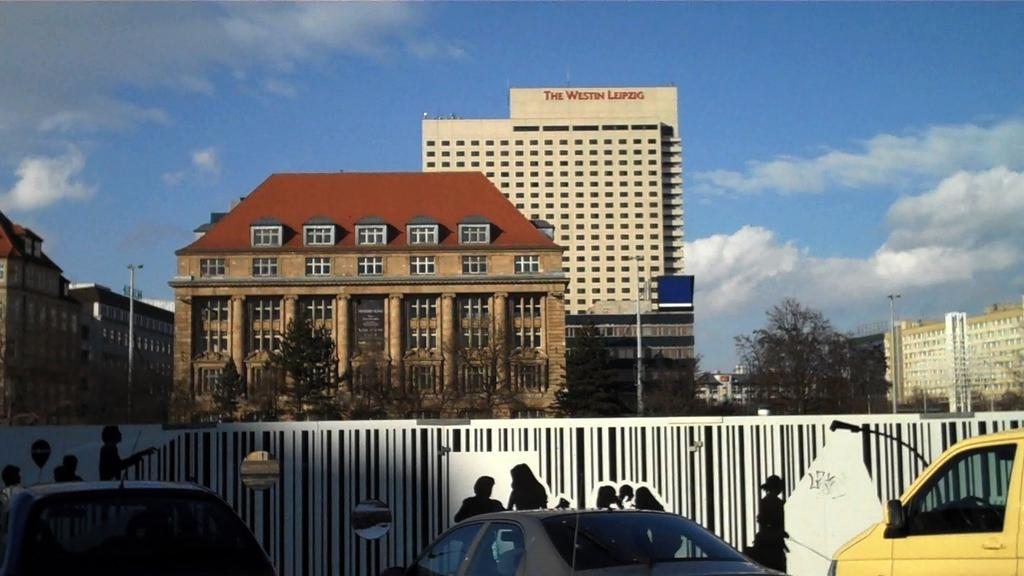What types of objects can be seen in the image? There are vehicles, a wall, poles, trees, and buildings in the image. What is on the wall in the image? There is a painting on the wall in the image. What can be seen in the background of the image? The sky is visible in the background of the image. What type of powder is being used to clean the vehicles in the image? There is no indication of any powder being used to clean the vehicles in the image. Can you see any rats in the image? There are no rats present in the image. 